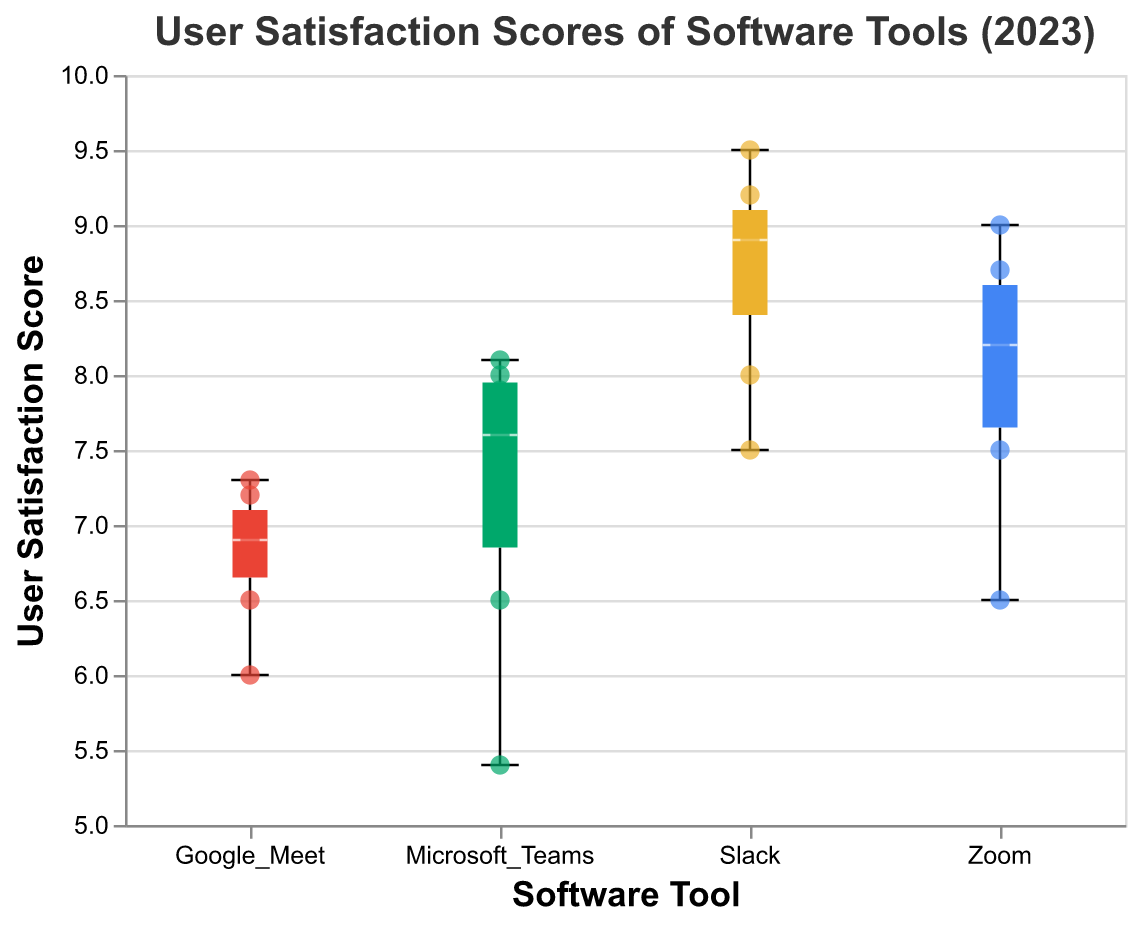What is the title of the chart? The title is displayed at the top of the chart in a larger font. It reads "User Satisfaction Scores of Software Tools (2023)."
Answer: User Satisfaction Scores of Software Tools (2023) Which software has the highest median user satisfaction score? To determine the software with the highest median score, look at the central line inside the boxes. The median value for Slack appears highest among all software tools.
Answer: Slack How many user satisfaction scores are shown for Google Meet? Count the individual scatter points for Google Meet. There are a total of 5 points indicating individual scores.
Answer: 5 What is the lowest user satisfaction score for Microsoft Teams? The lowest score is indicated by the bottom whisker of the boxplot for Microsoft Teams, which appears to be at 5.4.
Answer: 5.4 Which software tool has the largest range of user satisfaction scores? The range is the distance between the top and bottom whiskers of the boxplot. Slack has the largest range from around 7.5 to 9.5.
Answer: Slack Are there any outliers in the user satisfaction scores for Zoom? Outliers would typically be marked as individual points outside the whiskers of the boxplot. There are no points outside the whiskers for Zoom, indicating no outliers.
Answer: No What's the interquartile range (IQR) for Slack's user satisfaction scores? IQR is the difference between the third quartile (top of the box) and the first quartile (bottom of the box). For Slack, this ranges from about 8.0 to 9.1, so the IQR is approximately 9.1 - 8.0 = 1.1.
Answer: 1.1 Which software tool shows the most consistent user satisfaction scores? Consistency can be inferred from the smallest range in the boxplot. Google Meet has the smallest range, indicating the most consistent scores.
Answer: Google Meet What is the highest user satisfaction score for all software tools? The highest point across all scatter points determines this. For Slack, it reaches up to 9.5.
Answer: 9.5 